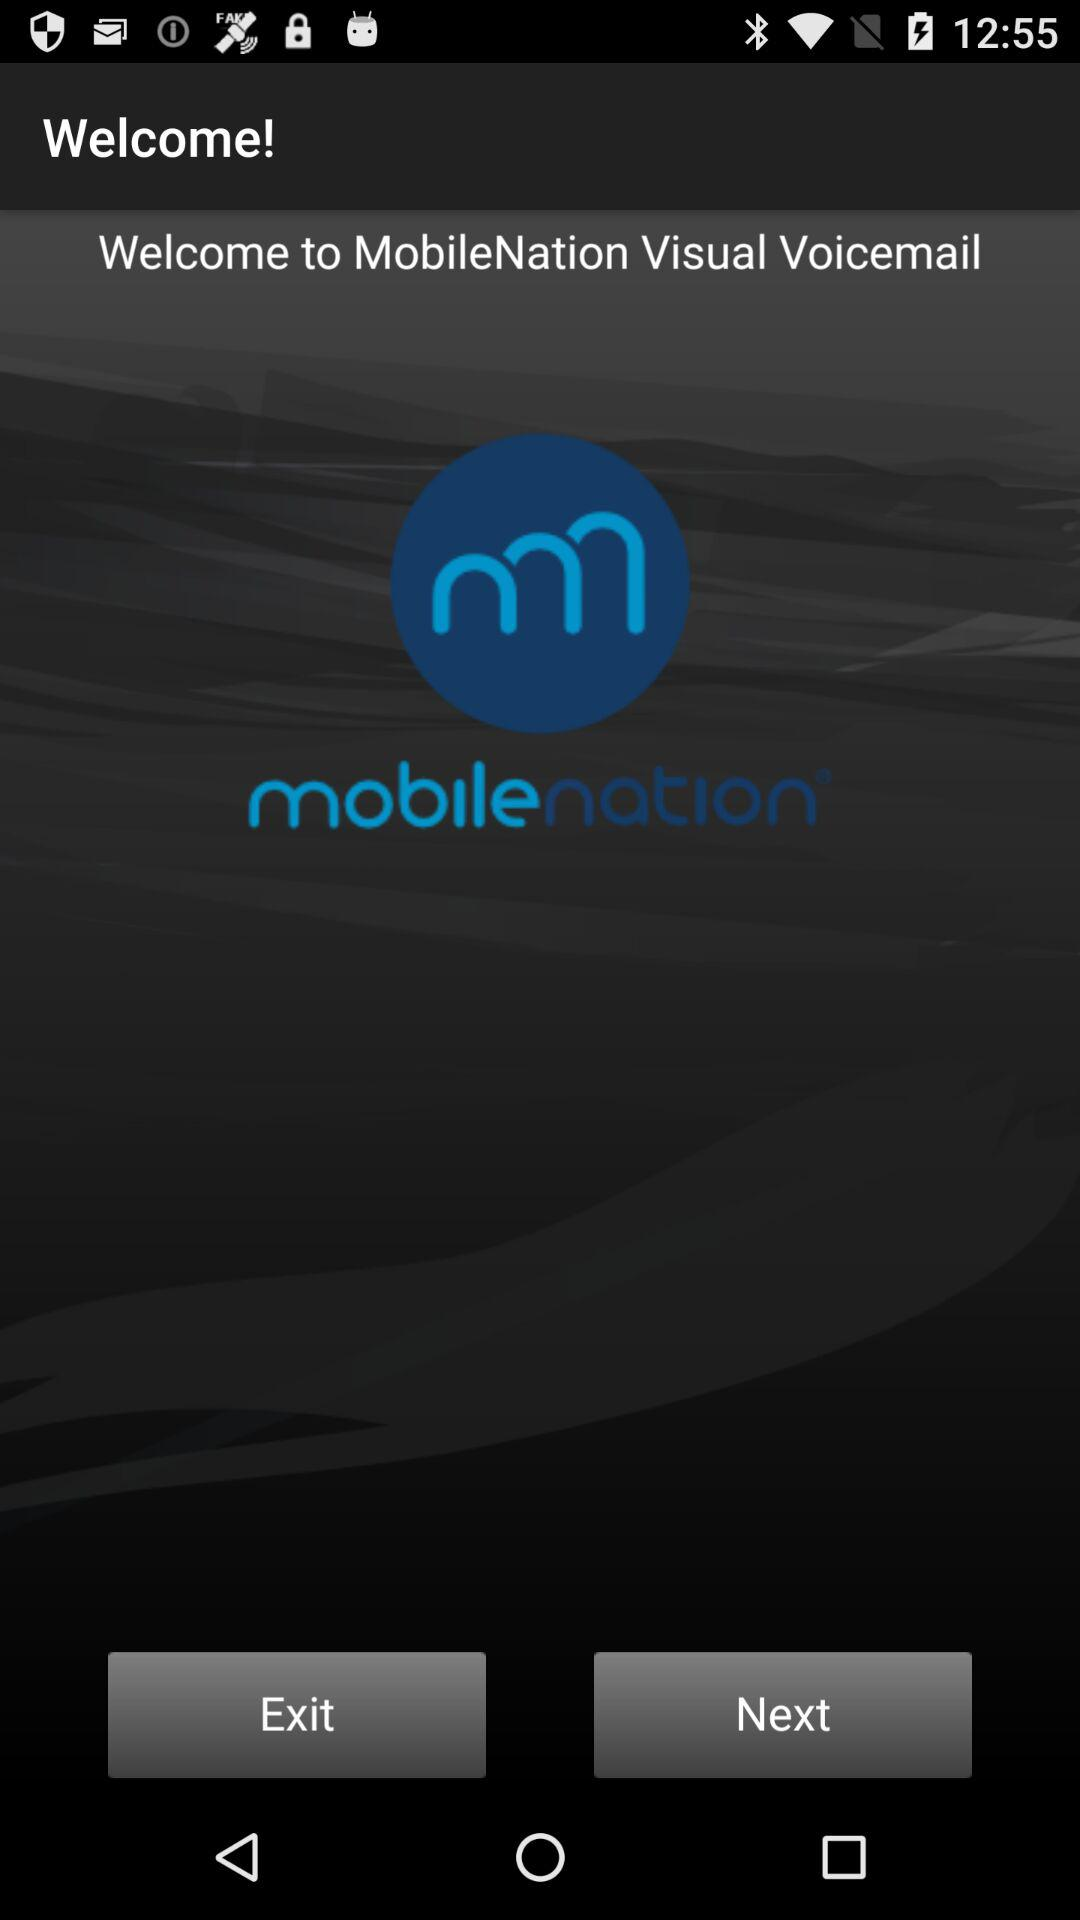What is the application name? The application name is "MobileNation Visual Voicemail". 